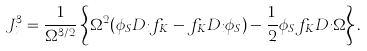Convert formula to latex. <formula><loc_0><loc_0><loc_500><loc_500>J _ { i } ^ { 3 } = \frac { 1 } { \Omega ^ { 3 / 2 } } \left \{ \Omega ^ { 2 } ( \phi _ { S } D _ { i } f _ { K } - f _ { K } D _ { i } \phi _ { S } ) - \frac { 1 } { 2 } \phi _ { S } f _ { K } D _ { i } \Omega \right \} .</formula> 